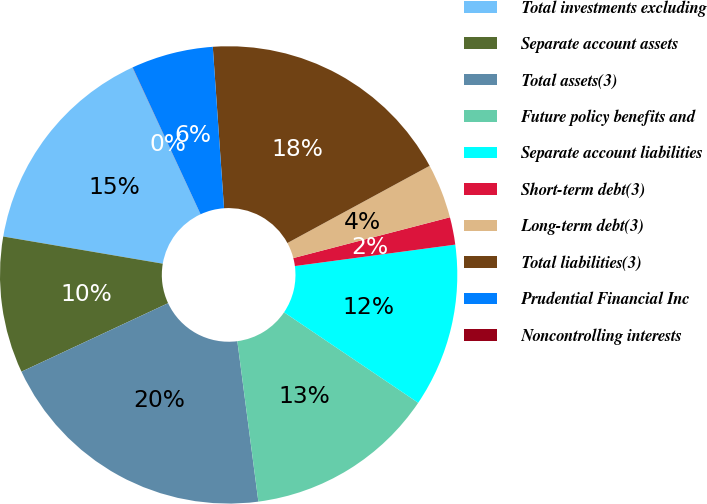Convert chart to OTSL. <chart><loc_0><loc_0><loc_500><loc_500><pie_chart><fcel>Total investments excluding<fcel>Separate account assets<fcel>Total assets(3)<fcel>Future policy benefits and<fcel>Separate account liabilities<fcel>Short-term debt(3)<fcel>Long-term debt(3)<fcel>Total liabilities(3)<fcel>Prudential Financial Inc<fcel>Noncontrolling interests<nl><fcel>15.41%<fcel>9.64%<fcel>20.12%<fcel>13.48%<fcel>11.56%<fcel>1.94%<fcel>3.86%<fcel>18.19%<fcel>5.79%<fcel>0.01%<nl></chart> 